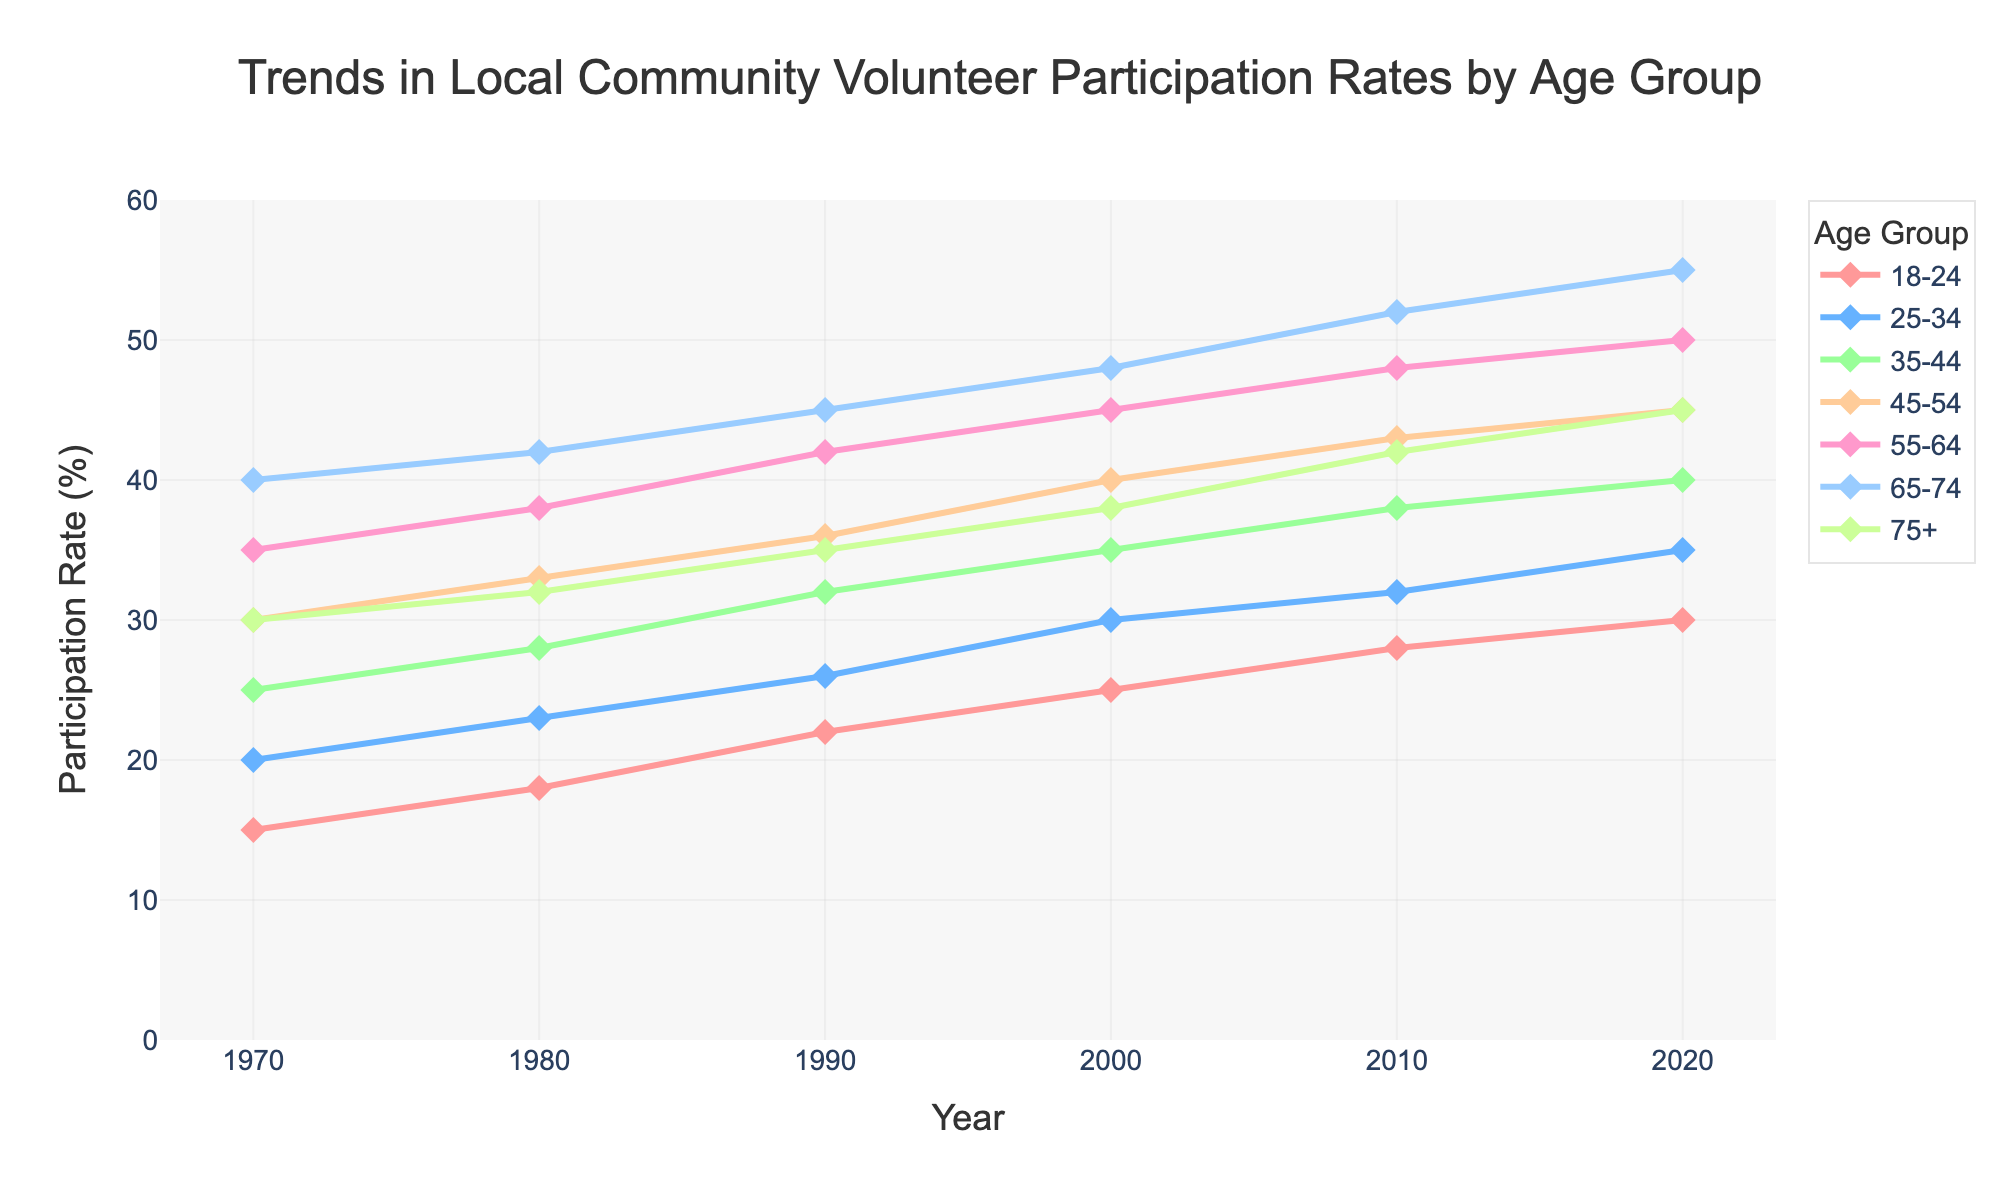what is the trend in the 18-24 age group's participation rate from 1970 to 2020? To see the trend, look at how the line representing the 18-24 age group's participation rate changes over the years. It starts at 15% in 1970 and increases to 30% in 2020. This shows a steady increase over the 50 years.
Answer: Steadily increasing which age group had the highest participation rate in 2020? Look at the y-axis values for the lines at the year 2020. The age group 65-74 is at the highest value, with a participation rate of 55%.
Answer: 65-74 compare the participation rates of the 25-34 and 45-54 age groups in 2010 Find the values where the lines representing these age groups intersect the 2010 marker on the x-axis. The 25-34 group is at 32%, while the 45-54 group is at 43%.
Answer: 25-34: 32%, 45-54: 43% by how much did the participation rate for the 35-44 age group increase from 1970 to 2000? The 35-44 age group's rate in 1970 is 25%, and in 2000, it is 35%. The increase is 35% - 25% = 10%.
Answer: 10% in which year did the 55-64 age group see its largest increase in participation rate? Look at the differences between adjacent years for the 55-64 age group. The largest increase is from 1980 to 1990, where the rate rose from 38% to 42%, a 4% increase.
Answer: 1980 to 1990 which age group had the smallest increase in participation rates over the 50 years? Calculate the increase for each age group by subtracting the 1970 rate from the 2020 rate. The 75+ age group increased from 30% to 45%, a 15% increase, which is the smallest among all groups.
Answer: 75+ what is the average participation rate for the 45-54 age group from 1970 to 2020? Add the values for 1970, 1980, 1990, 2000, 2010, and 2020 for the 45-54 age group: (30 + 33 + 36 + 40 + 43 + 45) = 227. Divide by the number of years, which is 6: 227 / 6 = 37.83.
Answer: 37.83% which age group showed the most consistent (least variable) increase in participation rates? Compare the slopes of the lines representing each age group. The 65-74 age group's line shows the most consistent and steady increase.
Answer: 65-74 